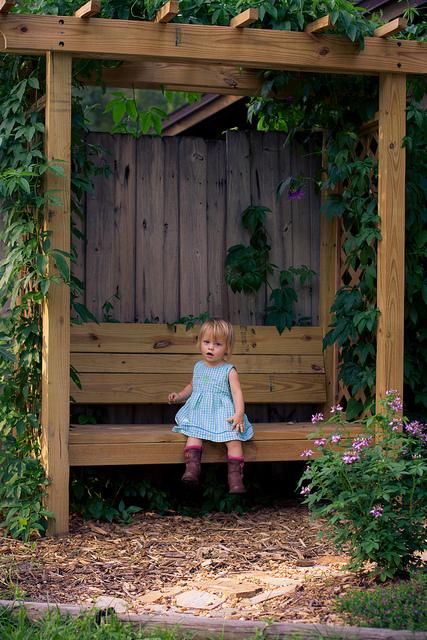Which direction is the child looking?
Short answer required. Forward. Where could one find shade?
Answer briefly. Bench. Has this photo been taken from inside a car?
Answer briefly. No. Is there a window scene?
Concise answer only. No. Is the child wearing rubber boots?
Quick response, please. Yes. What color is the bench?
Be succinct. Brown. How many dogs?
Write a very short answer. 0. What color is the bench roof?
Be succinct. Brown. Is anyone on the bench?
Keep it brief. Yes. Where is the girl sitting?
Concise answer only. Bench. Is the girl more than five years old?
Write a very short answer. No. Is the wood painted?
Short answer required. No. How many people are in the picture?
Give a very brief answer. 1. Does the bench look comfortable?
Keep it brief. Yes. How many people are sitting on the bench?
Concise answer only. 1. Is there a cat in the photo?
Keep it brief. No. Is there a teddy bear in this picture?
Quick response, please. No. Can the bench swing back and forth?
Write a very short answer. No. Is there anyone sitting on the bench?
Short answer required. Yes. 